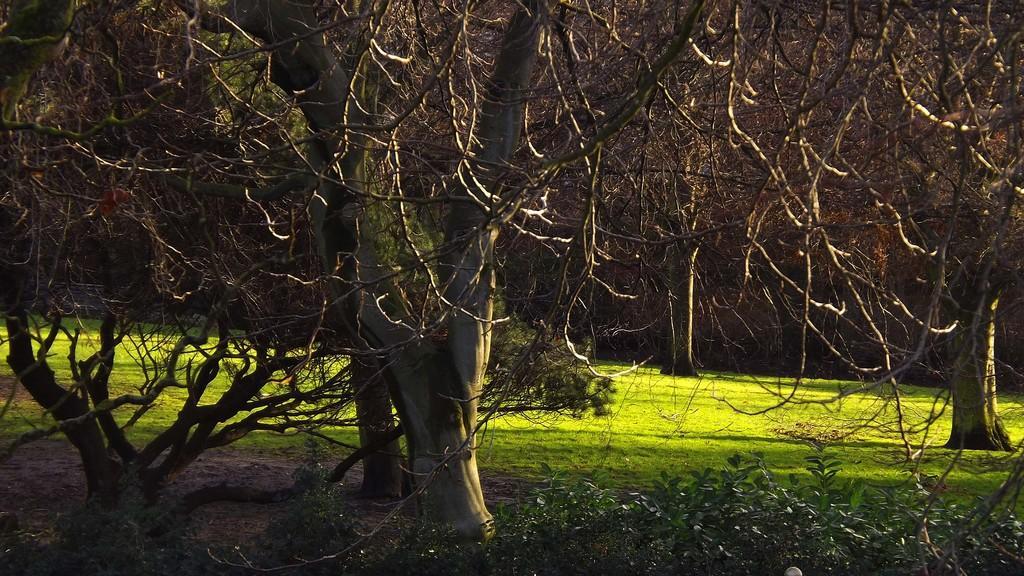Could you give a brief overview of what you see in this image? In this picture we can see the grass, plants, trees and in the background it is dark. 